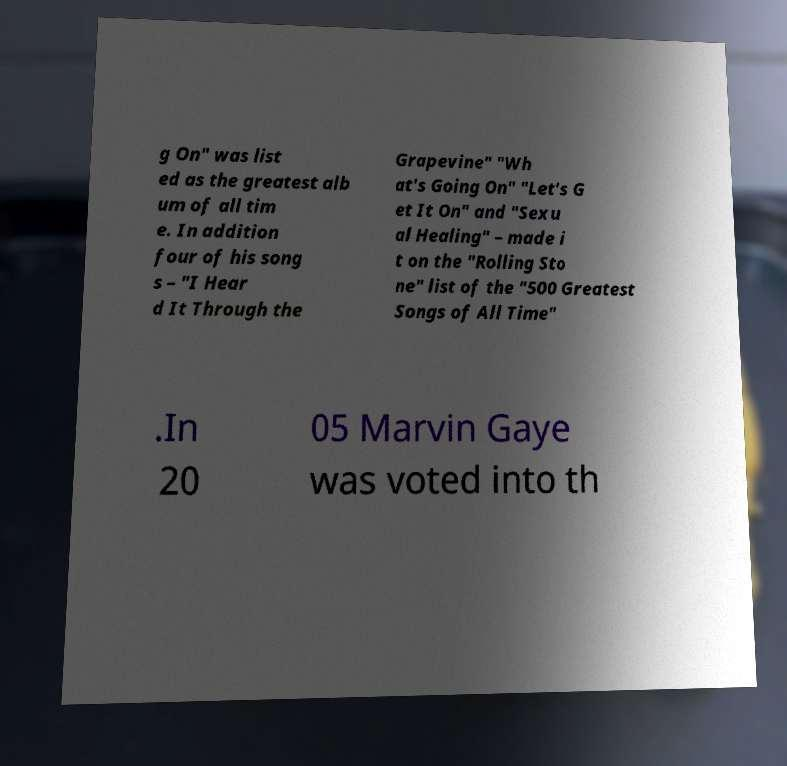Can you accurately transcribe the text from the provided image for me? g On" was list ed as the greatest alb um of all tim e. In addition four of his song s – "I Hear d It Through the Grapevine" "Wh at's Going On" "Let's G et It On" and "Sexu al Healing" – made i t on the "Rolling Sto ne" list of the "500 Greatest Songs of All Time" .In 20 05 Marvin Gaye was voted into th 